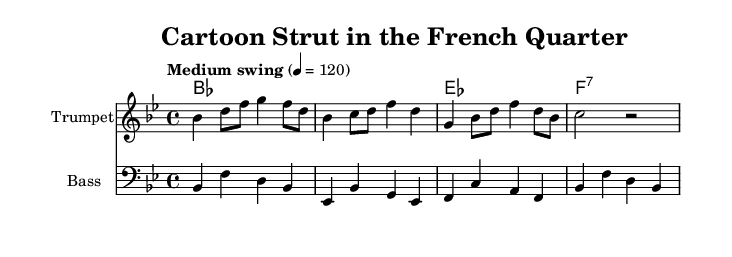What is the key signature of this music? The key signature is indicated by the sharp and flat symbols shown at the beginning. In this case, there are two flats, which corresponds to B-flat major.
Answer: B-flat major What is the time signature of the music? The time signature is found right after the key signature notation and indicates the meter of the music. Here, it shows a 4/4 time signature, meaning four beats per measure.
Answer: 4/4 What is the tempo marking for the piece? The tempo marking is usually indicated above the staff. In this case, "Medium swing" is the description provided, along with the metronome marking of 120, suggesting a swinging feel at this speed.
Answer: Medium swing How many measures are in the trumpet part? By counting the groups separated by bar lines in the trumpet music section, there are four measures, as each measure concludes before the vertical line reappears.
Answer: Four What is the chord that appears in the second measure? The symbols for the chords are listed in parallel with the staves, and the second measure indicates a B-flat major chord, which is notated as "B-flat."
Answer: B-flat Which instrument has the bass clef? The bass clef is specifically indicated in the music notation by the symbol that looks like a stylized 'F'. In this case, it is used for the bass part, clarifying its identity as the bass.
Answer: Bass What type of jazz theme is suggested by the title of the piece? The title "Cartoon Strut in the French Quarter" implies a whimsical and lively theme, associating it with animated and playful elements commonly found in cartoons.
Answer: Whimsical 